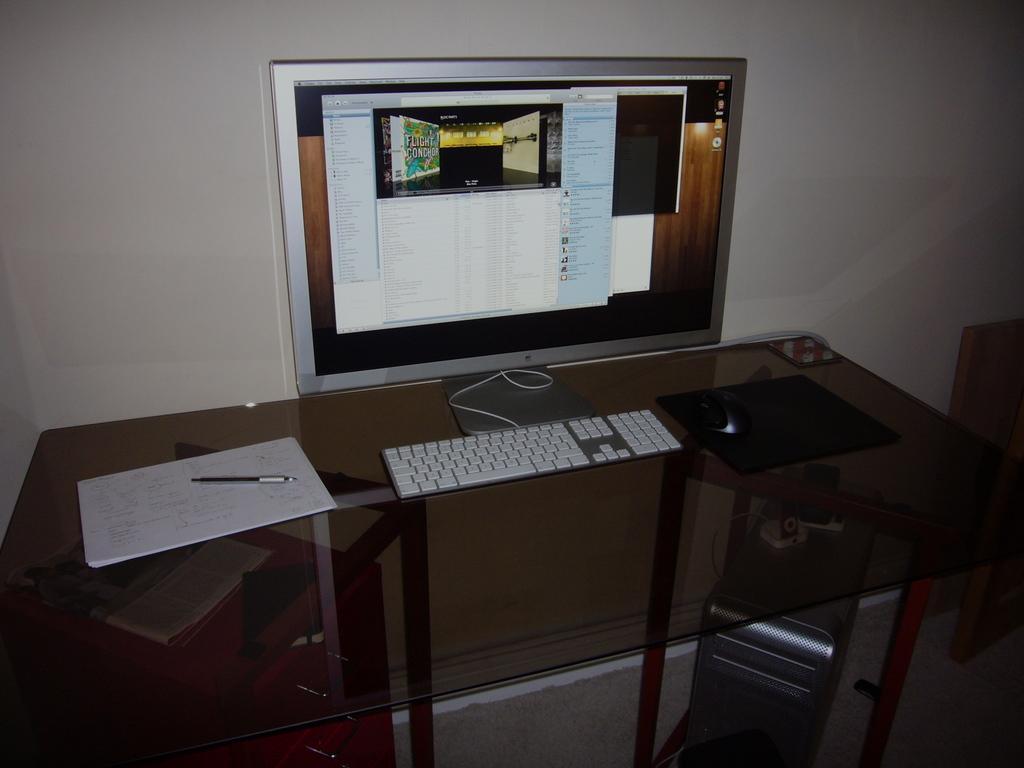How would you summarize this image in a sentence or two? There is a glass table, on the table there is a monitor,keyboard and a mouse and on the left side of the keyboard there is a paper and a pen, behind the table there is a wall and there is a CPU kept under the table. 